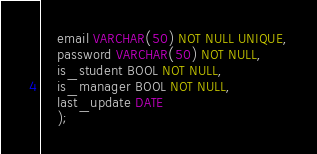<code> <loc_0><loc_0><loc_500><loc_500><_SQL_>    email VARCHAR(50) NOT NULL UNIQUE,
    password VARCHAR(50) NOT NULL,
    is_student BOOL NOT NULL,
    is_manager BOOL NOT NULL,
    last_update DATE
    );

</code> 